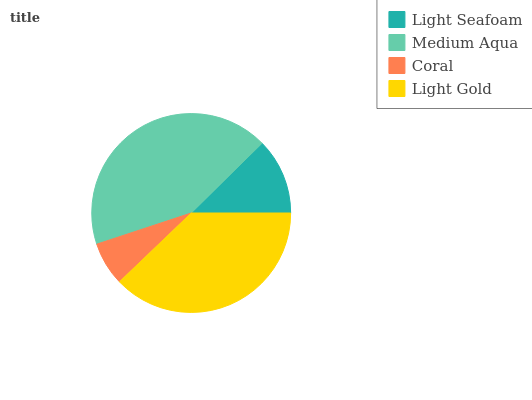Is Coral the minimum?
Answer yes or no. Yes. Is Medium Aqua the maximum?
Answer yes or no. Yes. Is Medium Aqua the minimum?
Answer yes or no. No. Is Coral the maximum?
Answer yes or no. No. Is Medium Aqua greater than Coral?
Answer yes or no. Yes. Is Coral less than Medium Aqua?
Answer yes or no. Yes. Is Coral greater than Medium Aqua?
Answer yes or no. No. Is Medium Aqua less than Coral?
Answer yes or no. No. Is Light Gold the high median?
Answer yes or no. Yes. Is Light Seafoam the low median?
Answer yes or no. Yes. Is Coral the high median?
Answer yes or no. No. Is Light Gold the low median?
Answer yes or no. No. 